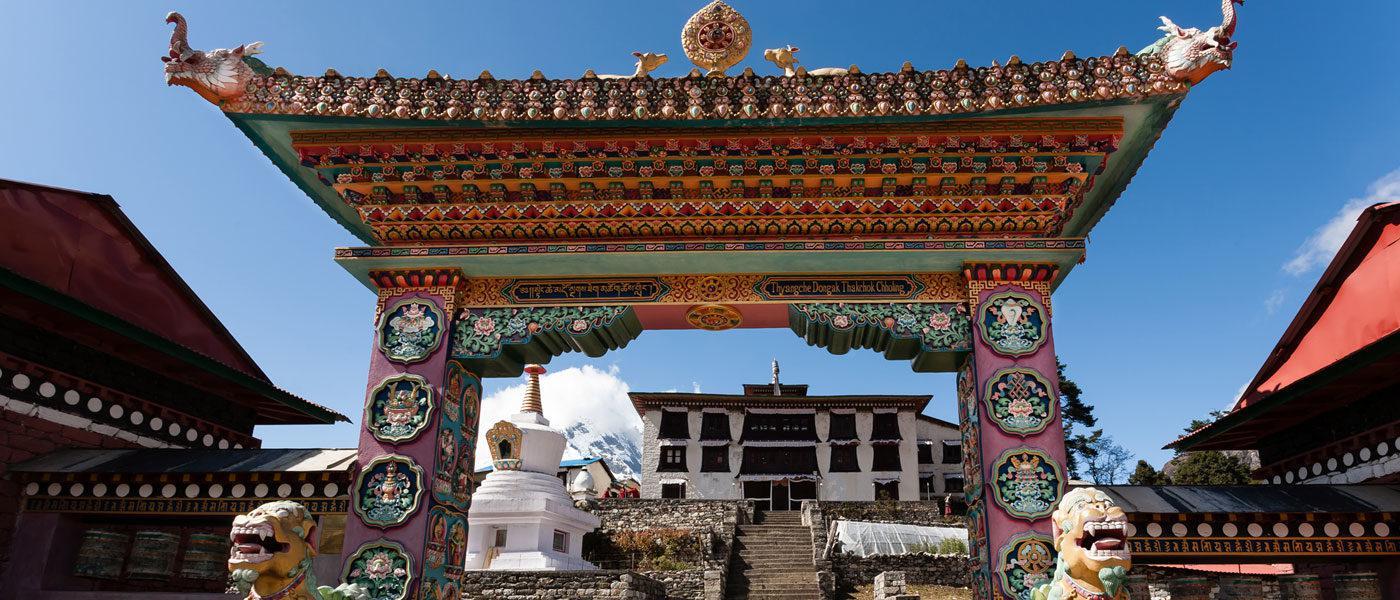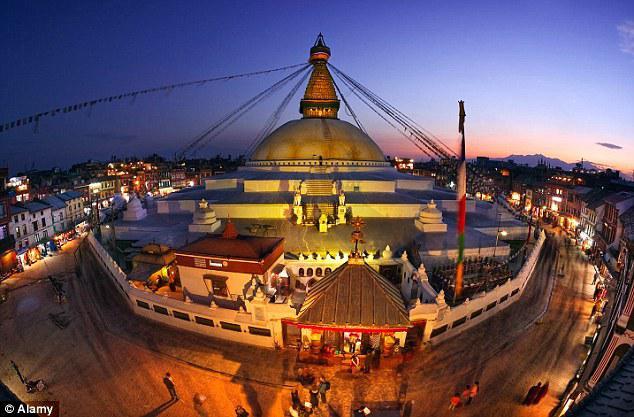The first image is the image on the left, the second image is the image on the right. Assess this claim about the two images: "Both images are of the inside of a room.". Correct or not? Answer yes or no. No. The first image is the image on the left, the second image is the image on the right. Analyze the images presented: Is the assertion "The left and right image contains the same number of inside monasteries." valid? Answer yes or no. No. 